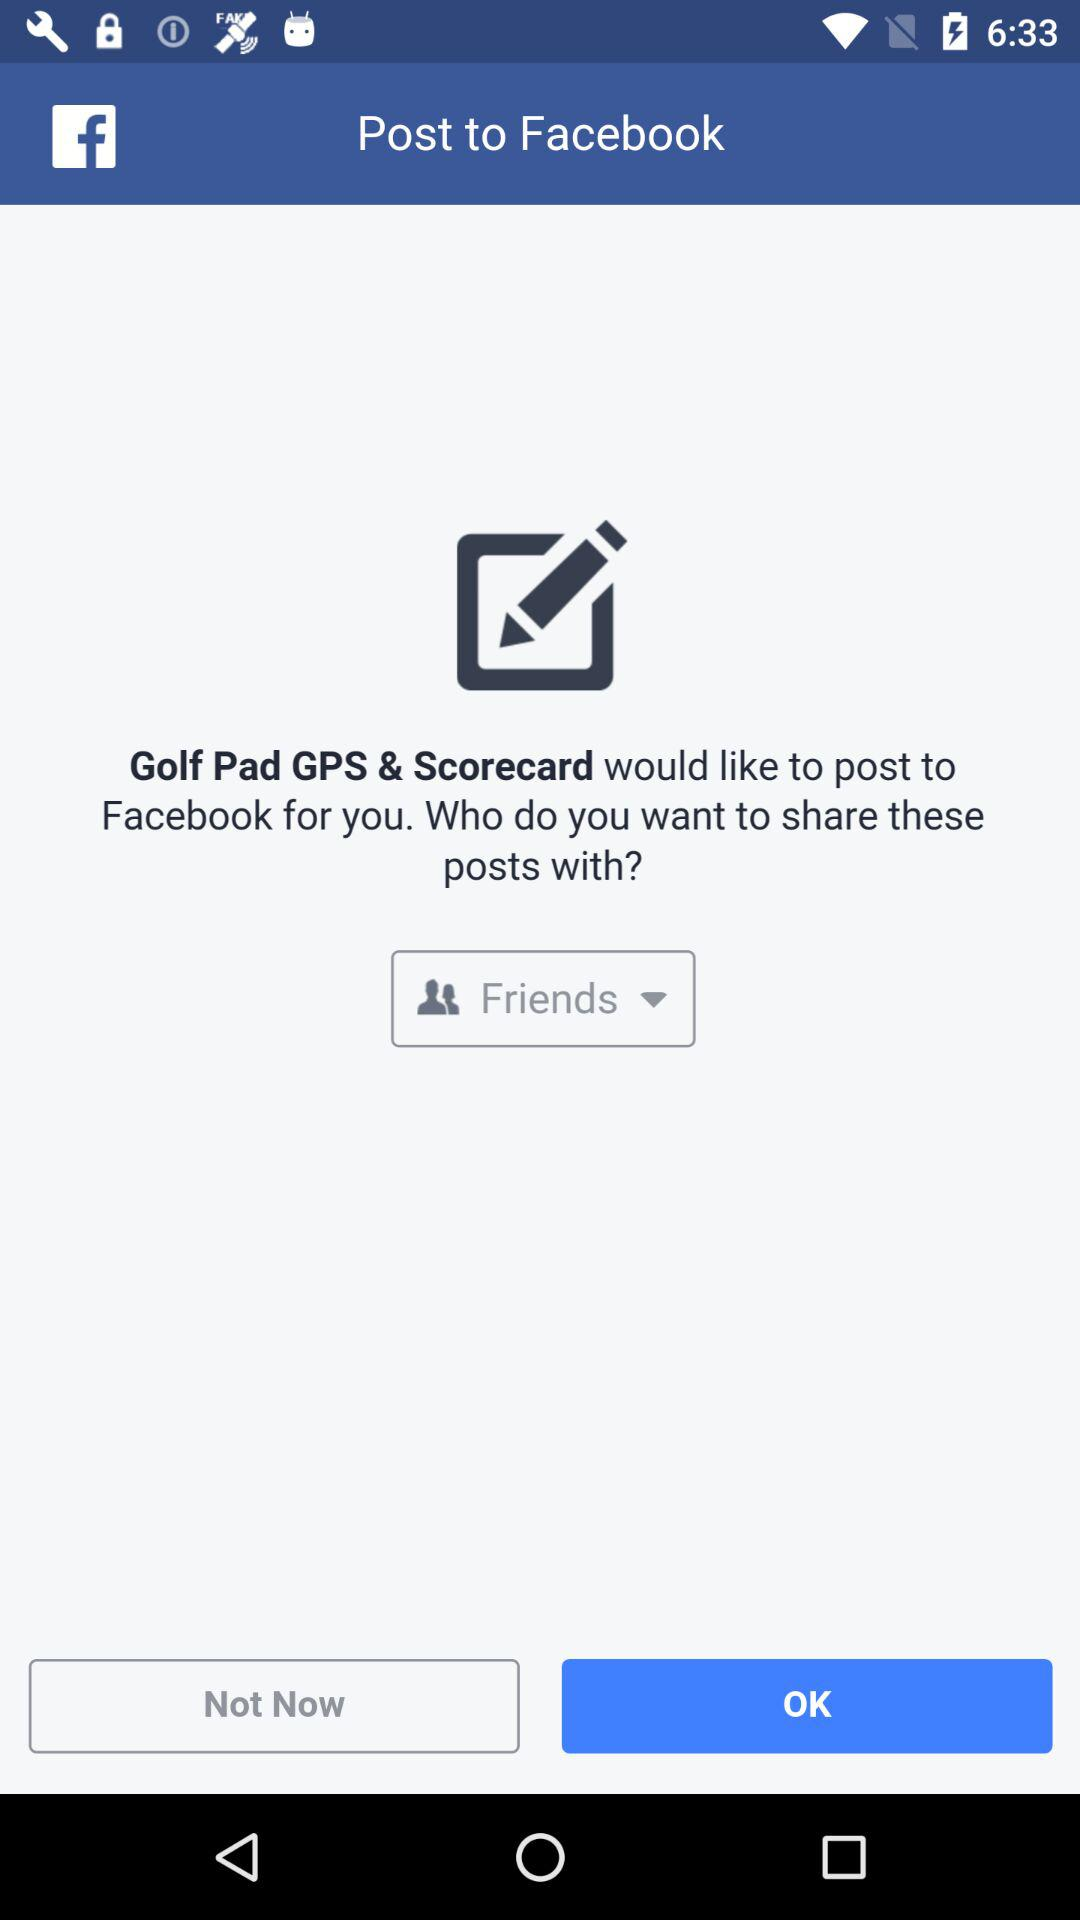Which sharing options are available in the drop-down menu?
When the provided information is insufficient, respond with <no answer>. <no answer> 